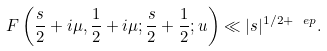<formula> <loc_0><loc_0><loc_500><loc_500>F \left ( \frac { s } { 2 } + i \mu , \frac { 1 } { 2 } + i \mu ; \frac { s } { 2 } + \frac { 1 } { 2 } ; u \right ) \ll | s | ^ { 1 / 2 + \ e p } .</formula> 